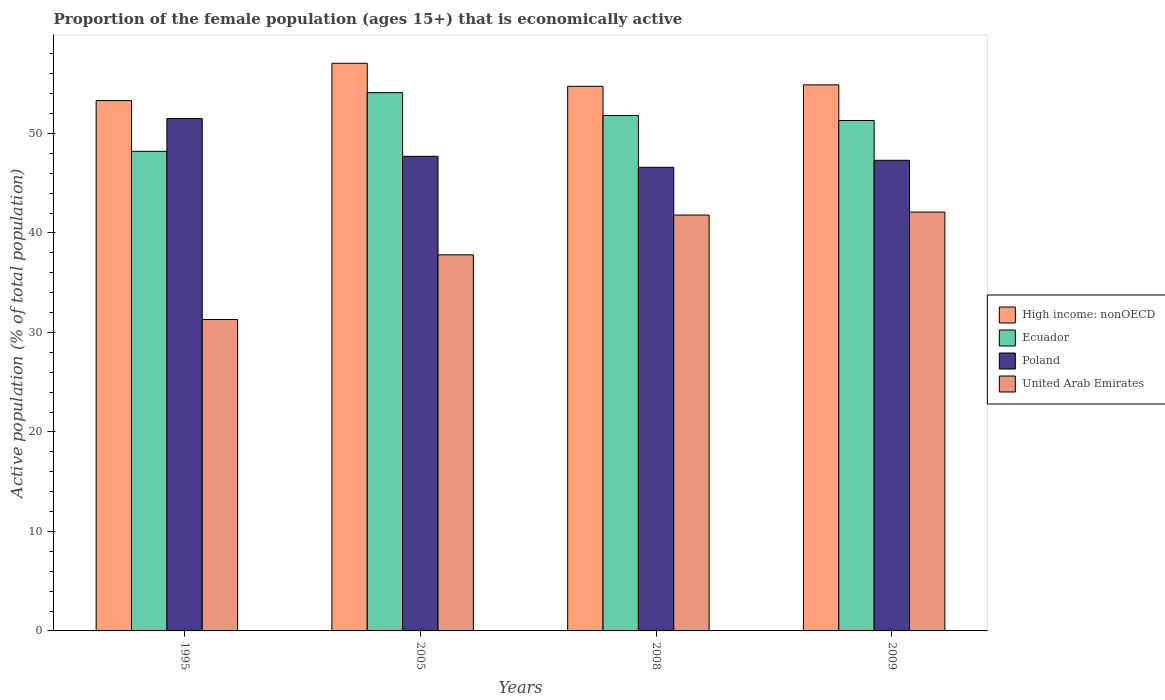How many different coloured bars are there?
Your answer should be compact. 4. Are the number of bars per tick equal to the number of legend labels?
Make the answer very short. Yes. Are the number of bars on each tick of the X-axis equal?
Ensure brevity in your answer.  Yes. How many bars are there on the 1st tick from the left?
Offer a terse response. 4. How many bars are there on the 2nd tick from the right?
Make the answer very short. 4. What is the proportion of the female population that is economically active in Ecuador in 2009?
Provide a succinct answer. 51.3. Across all years, what is the maximum proportion of the female population that is economically active in Poland?
Ensure brevity in your answer.  51.5. Across all years, what is the minimum proportion of the female population that is economically active in Ecuador?
Your answer should be very brief. 48.2. In which year was the proportion of the female population that is economically active in Ecuador minimum?
Provide a short and direct response. 1995. What is the total proportion of the female population that is economically active in High income: nonOECD in the graph?
Ensure brevity in your answer.  219.98. What is the difference between the proportion of the female population that is economically active in High income: nonOECD in 2005 and that in 2009?
Provide a succinct answer. 2.17. What is the average proportion of the female population that is economically active in United Arab Emirates per year?
Make the answer very short. 38.25. In the year 2009, what is the difference between the proportion of the female population that is economically active in Ecuador and proportion of the female population that is economically active in United Arab Emirates?
Ensure brevity in your answer.  9.2. What is the ratio of the proportion of the female population that is economically active in United Arab Emirates in 1995 to that in 2008?
Make the answer very short. 0.75. Is the proportion of the female population that is economically active in High income: nonOECD in 1995 less than that in 2005?
Provide a succinct answer. Yes. Is the difference between the proportion of the female population that is economically active in Ecuador in 1995 and 2009 greater than the difference between the proportion of the female population that is economically active in United Arab Emirates in 1995 and 2009?
Give a very brief answer. Yes. What is the difference between the highest and the second highest proportion of the female population that is economically active in High income: nonOECD?
Offer a very short reply. 2.17. What is the difference between the highest and the lowest proportion of the female population that is economically active in Ecuador?
Your response must be concise. 5.9. In how many years, is the proportion of the female population that is economically active in High income: nonOECD greater than the average proportion of the female population that is economically active in High income: nonOECD taken over all years?
Make the answer very short. 1. Is the sum of the proportion of the female population that is economically active in United Arab Emirates in 1995 and 2008 greater than the maximum proportion of the female population that is economically active in Poland across all years?
Offer a very short reply. Yes. Is it the case that in every year, the sum of the proportion of the female population that is economically active in Poland and proportion of the female population that is economically active in United Arab Emirates is greater than the sum of proportion of the female population that is economically active in High income: nonOECD and proportion of the female population that is economically active in Ecuador?
Make the answer very short. Yes. What does the 1st bar from the left in 1995 represents?
Your answer should be compact. High income: nonOECD. What does the 3rd bar from the right in 2009 represents?
Ensure brevity in your answer.  Ecuador. How many bars are there?
Your answer should be very brief. 16. What is the difference between two consecutive major ticks on the Y-axis?
Offer a terse response. 10. Are the values on the major ticks of Y-axis written in scientific E-notation?
Your response must be concise. No. Does the graph contain any zero values?
Give a very brief answer. No. How many legend labels are there?
Offer a very short reply. 4. What is the title of the graph?
Your response must be concise. Proportion of the female population (ages 15+) that is economically active. What is the label or title of the X-axis?
Keep it short and to the point. Years. What is the label or title of the Y-axis?
Offer a very short reply. Active population (% of total population). What is the Active population (% of total population) in High income: nonOECD in 1995?
Provide a succinct answer. 53.3. What is the Active population (% of total population) in Ecuador in 1995?
Keep it short and to the point. 48.2. What is the Active population (% of total population) of Poland in 1995?
Provide a short and direct response. 51.5. What is the Active population (% of total population) in United Arab Emirates in 1995?
Provide a succinct answer. 31.3. What is the Active population (% of total population) of High income: nonOECD in 2005?
Offer a terse response. 57.05. What is the Active population (% of total population) of Ecuador in 2005?
Keep it short and to the point. 54.1. What is the Active population (% of total population) of Poland in 2005?
Offer a terse response. 47.7. What is the Active population (% of total population) in United Arab Emirates in 2005?
Offer a terse response. 37.8. What is the Active population (% of total population) in High income: nonOECD in 2008?
Ensure brevity in your answer.  54.74. What is the Active population (% of total population) of Ecuador in 2008?
Your answer should be compact. 51.8. What is the Active population (% of total population) of Poland in 2008?
Offer a very short reply. 46.6. What is the Active population (% of total population) of United Arab Emirates in 2008?
Offer a very short reply. 41.8. What is the Active population (% of total population) of High income: nonOECD in 2009?
Ensure brevity in your answer.  54.88. What is the Active population (% of total population) of Ecuador in 2009?
Keep it short and to the point. 51.3. What is the Active population (% of total population) in Poland in 2009?
Offer a very short reply. 47.3. What is the Active population (% of total population) of United Arab Emirates in 2009?
Your answer should be very brief. 42.1. Across all years, what is the maximum Active population (% of total population) in High income: nonOECD?
Offer a very short reply. 57.05. Across all years, what is the maximum Active population (% of total population) of Ecuador?
Provide a succinct answer. 54.1. Across all years, what is the maximum Active population (% of total population) in Poland?
Your answer should be very brief. 51.5. Across all years, what is the maximum Active population (% of total population) of United Arab Emirates?
Your answer should be compact. 42.1. Across all years, what is the minimum Active population (% of total population) in High income: nonOECD?
Your response must be concise. 53.3. Across all years, what is the minimum Active population (% of total population) in Ecuador?
Provide a short and direct response. 48.2. Across all years, what is the minimum Active population (% of total population) of Poland?
Keep it short and to the point. 46.6. Across all years, what is the minimum Active population (% of total population) of United Arab Emirates?
Offer a terse response. 31.3. What is the total Active population (% of total population) in High income: nonOECD in the graph?
Make the answer very short. 219.98. What is the total Active population (% of total population) of Ecuador in the graph?
Give a very brief answer. 205.4. What is the total Active population (% of total population) of Poland in the graph?
Your answer should be very brief. 193.1. What is the total Active population (% of total population) of United Arab Emirates in the graph?
Ensure brevity in your answer.  153. What is the difference between the Active population (% of total population) of High income: nonOECD in 1995 and that in 2005?
Provide a succinct answer. -3.75. What is the difference between the Active population (% of total population) in Poland in 1995 and that in 2005?
Provide a succinct answer. 3.8. What is the difference between the Active population (% of total population) in United Arab Emirates in 1995 and that in 2005?
Give a very brief answer. -6.5. What is the difference between the Active population (% of total population) in High income: nonOECD in 1995 and that in 2008?
Ensure brevity in your answer.  -1.43. What is the difference between the Active population (% of total population) of Poland in 1995 and that in 2008?
Your answer should be compact. 4.9. What is the difference between the Active population (% of total population) in High income: nonOECD in 1995 and that in 2009?
Offer a very short reply. -1.58. What is the difference between the Active population (% of total population) in Poland in 1995 and that in 2009?
Your answer should be very brief. 4.2. What is the difference between the Active population (% of total population) in United Arab Emirates in 1995 and that in 2009?
Keep it short and to the point. -10.8. What is the difference between the Active population (% of total population) of High income: nonOECD in 2005 and that in 2008?
Your answer should be very brief. 2.32. What is the difference between the Active population (% of total population) of Ecuador in 2005 and that in 2008?
Keep it short and to the point. 2.3. What is the difference between the Active population (% of total population) in High income: nonOECD in 2005 and that in 2009?
Make the answer very short. 2.17. What is the difference between the Active population (% of total population) of Ecuador in 2005 and that in 2009?
Ensure brevity in your answer.  2.8. What is the difference between the Active population (% of total population) of Poland in 2005 and that in 2009?
Make the answer very short. 0.4. What is the difference between the Active population (% of total population) of High income: nonOECD in 2008 and that in 2009?
Ensure brevity in your answer.  -0.15. What is the difference between the Active population (% of total population) in Poland in 2008 and that in 2009?
Your answer should be very brief. -0.7. What is the difference between the Active population (% of total population) of United Arab Emirates in 2008 and that in 2009?
Ensure brevity in your answer.  -0.3. What is the difference between the Active population (% of total population) of High income: nonOECD in 1995 and the Active population (% of total population) of Ecuador in 2005?
Make the answer very short. -0.8. What is the difference between the Active population (% of total population) of High income: nonOECD in 1995 and the Active population (% of total population) of Poland in 2005?
Keep it short and to the point. 5.6. What is the difference between the Active population (% of total population) of High income: nonOECD in 1995 and the Active population (% of total population) of United Arab Emirates in 2005?
Keep it short and to the point. 15.5. What is the difference between the Active population (% of total population) in High income: nonOECD in 1995 and the Active population (% of total population) in Ecuador in 2008?
Make the answer very short. 1.5. What is the difference between the Active population (% of total population) of High income: nonOECD in 1995 and the Active population (% of total population) of Poland in 2008?
Make the answer very short. 6.7. What is the difference between the Active population (% of total population) in High income: nonOECD in 1995 and the Active population (% of total population) in United Arab Emirates in 2008?
Your answer should be compact. 11.5. What is the difference between the Active population (% of total population) of Ecuador in 1995 and the Active population (% of total population) of Poland in 2008?
Provide a short and direct response. 1.6. What is the difference between the Active population (% of total population) of Ecuador in 1995 and the Active population (% of total population) of United Arab Emirates in 2008?
Provide a succinct answer. 6.4. What is the difference between the Active population (% of total population) in Poland in 1995 and the Active population (% of total population) in United Arab Emirates in 2008?
Offer a terse response. 9.7. What is the difference between the Active population (% of total population) of High income: nonOECD in 1995 and the Active population (% of total population) of Ecuador in 2009?
Make the answer very short. 2. What is the difference between the Active population (% of total population) of High income: nonOECD in 1995 and the Active population (% of total population) of Poland in 2009?
Ensure brevity in your answer.  6. What is the difference between the Active population (% of total population) of High income: nonOECD in 1995 and the Active population (% of total population) of United Arab Emirates in 2009?
Give a very brief answer. 11.2. What is the difference between the Active population (% of total population) in Ecuador in 1995 and the Active population (% of total population) in United Arab Emirates in 2009?
Make the answer very short. 6.1. What is the difference between the Active population (% of total population) in High income: nonOECD in 2005 and the Active population (% of total population) in Ecuador in 2008?
Make the answer very short. 5.25. What is the difference between the Active population (% of total population) of High income: nonOECD in 2005 and the Active population (% of total population) of Poland in 2008?
Offer a very short reply. 10.45. What is the difference between the Active population (% of total population) in High income: nonOECD in 2005 and the Active population (% of total population) in United Arab Emirates in 2008?
Give a very brief answer. 15.25. What is the difference between the Active population (% of total population) in Ecuador in 2005 and the Active population (% of total population) in United Arab Emirates in 2008?
Offer a terse response. 12.3. What is the difference between the Active population (% of total population) of Poland in 2005 and the Active population (% of total population) of United Arab Emirates in 2008?
Keep it short and to the point. 5.9. What is the difference between the Active population (% of total population) of High income: nonOECD in 2005 and the Active population (% of total population) of Ecuador in 2009?
Keep it short and to the point. 5.75. What is the difference between the Active population (% of total population) of High income: nonOECD in 2005 and the Active population (% of total population) of Poland in 2009?
Your answer should be very brief. 9.75. What is the difference between the Active population (% of total population) in High income: nonOECD in 2005 and the Active population (% of total population) in United Arab Emirates in 2009?
Provide a short and direct response. 14.95. What is the difference between the Active population (% of total population) in Ecuador in 2005 and the Active population (% of total population) in Poland in 2009?
Your response must be concise. 6.8. What is the difference between the Active population (% of total population) of Poland in 2005 and the Active population (% of total population) of United Arab Emirates in 2009?
Keep it short and to the point. 5.6. What is the difference between the Active population (% of total population) in High income: nonOECD in 2008 and the Active population (% of total population) in Ecuador in 2009?
Keep it short and to the point. 3.44. What is the difference between the Active population (% of total population) in High income: nonOECD in 2008 and the Active population (% of total population) in Poland in 2009?
Keep it short and to the point. 7.44. What is the difference between the Active population (% of total population) of High income: nonOECD in 2008 and the Active population (% of total population) of United Arab Emirates in 2009?
Give a very brief answer. 12.64. What is the difference between the Active population (% of total population) of Ecuador in 2008 and the Active population (% of total population) of United Arab Emirates in 2009?
Offer a very short reply. 9.7. What is the average Active population (% of total population) in High income: nonOECD per year?
Give a very brief answer. 54.99. What is the average Active population (% of total population) in Ecuador per year?
Give a very brief answer. 51.35. What is the average Active population (% of total population) of Poland per year?
Provide a succinct answer. 48.27. What is the average Active population (% of total population) of United Arab Emirates per year?
Make the answer very short. 38.25. In the year 1995, what is the difference between the Active population (% of total population) in High income: nonOECD and Active population (% of total population) in Ecuador?
Your answer should be very brief. 5.1. In the year 1995, what is the difference between the Active population (% of total population) in High income: nonOECD and Active population (% of total population) in Poland?
Keep it short and to the point. 1.8. In the year 1995, what is the difference between the Active population (% of total population) in High income: nonOECD and Active population (% of total population) in United Arab Emirates?
Make the answer very short. 22. In the year 1995, what is the difference between the Active population (% of total population) in Ecuador and Active population (% of total population) in Poland?
Provide a short and direct response. -3.3. In the year 1995, what is the difference between the Active population (% of total population) of Ecuador and Active population (% of total population) of United Arab Emirates?
Your answer should be compact. 16.9. In the year 1995, what is the difference between the Active population (% of total population) in Poland and Active population (% of total population) in United Arab Emirates?
Provide a short and direct response. 20.2. In the year 2005, what is the difference between the Active population (% of total population) of High income: nonOECD and Active population (% of total population) of Ecuador?
Offer a very short reply. 2.95. In the year 2005, what is the difference between the Active population (% of total population) in High income: nonOECD and Active population (% of total population) in Poland?
Your answer should be very brief. 9.35. In the year 2005, what is the difference between the Active population (% of total population) in High income: nonOECD and Active population (% of total population) in United Arab Emirates?
Keep it short and to the point. 19.25. In the year 2005, what is the difference between the Active population (% of total population) in Ecuador and Active population (% of total population) in Poland?
Your answer should be compact. 6.4. In the year 2005, what is the difference between the Active population (% of total population) of Poland and Active population (% of total population) of United Arab Emirates?
Offer a terse response. 9.9. In the year 2008, what is the difference between the Active population (% of total population) of High income: nonOECD and Active population (% of total population) of Ecuador?
Offer a terse response. 2.94. In the year 2008, what is the difference between the Active population (% of total population) of High income: nonOECD and Active population (% of total population) of Poland?
Offer a terse response. 8.14. In the year 2008, what is the difference between the Active population (% of total population) in High income: nonOECD and Active population (% of total population) in United Arab Emirates?
Make the answer very short. 12.94. In the year 2009, what is the difference between the Active population (% of total population) of High income: nonOECD and Active population (% of total population) of Ecuador?
Your answer should be compact. 3.58. In the year 2009, what is the difference between the Active population (% of total population) of High income: nonOECD and Active population (% of total population) of Poland?
Offer a very short reply. 7.58. In the year 2009, what is the difference between the Active population (% of total population) in High income: nonOECD and Active population (% of total population) in United Arab Emirates?
Offer a terse response. 12.78. In the year 2009, what is the difference between the Active population (% of total population) of Poland and Active population (% of total population) of United Arab Emirates?
Provide a succinct answer. 5.2. What is the ratio of the Active population (% of total population) in High income: nonOECD in 1995 to that in 2005?
Offer a very short reply. 0.93. What is the ratio of the Active population (% of total population) of Ecuador in 1995 to that in 2005?
Your response must be concise. 0.89. What is the ratio of the Active population (% of total population) of Poland in 1995 to that in 2005?
Give a very brief answer. 1.08. What is the ratio of the Active population (% of total population) of United Arab Emirates in 1995 to that in 2005?
Ensure brevity in your answer.  0.83. What is the ratio of the Active population (% of total population) of High income: nonOECD in 1995 to that in 2008?
Provide a succinct answer. 0.97. What is the ratio of the Active population (% of total population) in Ecuador in 1995 to that in 2008?
Ensure brevity in your answer.  0.93. What is the ratio of the Active population (% of total population) of Poland in 1995 to that in 2008?
Your answer should be very brief. 1.11. What is the ratio of the Active population (% of total population) in United Arab Emirates in 1995 to that in 2008?
Ensure brevity in your answer.  0.75. What is the ratio of the Active population (% of total population) of High income: nonOECD in 1995 to that in 2009?
Make the answer very short. 0.97. What is the ratio of the Active population (% of total population) of Ecuador in 1995 to that in 2009?
Your answer should be very brief. 0.94. What is the ratio of the Active population (% of total population) in Poland in 1995 to that in 2009?
Offer a very short reply. 1.09. What is the ratio of the Active population (% of total population) of United Arab Emirates in 1995 to that in 2009?
Your answer should be very brief. 0.74. What is the ratio of the Active population (% of total population) in High income: nonOECD in 2005 to that in 2008?
Provide a succinct answer. 1.04. What is the ratio of the Active population (% of total population) of Ecuador in 2005 to that in 2008?
Provide a succinct answer. 1.04. What is the ratio of the Active population (% of total population) in Poland in 2005 to that in 2008?
Give a very brief answer. 1.02. What is the ratio of the Active population (% of total population) in United Arab Emirates in 2005 to that in 2008?
Offer a very short reply. 0.9. What is the ratio of the Active population (% of total population) of High income: nonOECD in 2005 to that in 2009?
Your answer should be very brief. 1.04. What is the ratio of the Active population (% of total population) of Ecuador in 2005 to that in 2009?
Offer a terse response. 1.05. What is the ratio of the Active population (% of total population) in Poland in 2005 to that in 2009?
Keep it short and to the point. 1.01. What is the ratio of the Active population (% of total population) of United Arab Emirates in 2005 to that in 2009?
Your response must be concise. 0.9. What is the ratio of the Active population (% of total population) in Ecuador in 2008 to that in 2009?
Ensure brevity in your answer.  1.01. What is the ratio of the Active population (% of total population) in Poland in 2008 to that in 2009?
Give a very brief answer. 0.99. What is the ratio of the Active population (% of total population) in United Arab Emirates in 2008 to that in 2009?
Keep it short and to the point. 0.99. What is the difference between the highest and the second highest Active population (% of total population) of High income: nonOECD?
Ensure brevity in your answer.  2.17. What is the difference between the highest and the second highest Active population (% of total population) of Ecuador?
Keep it short and to the point. 2.3. What is the difference between the highest and the second highest Active population (% of total population) of Poland?
Offer a very short reply. 3.8. What is the difference between the highest and the second highest Active population (% of total population) in United Arab Emirates?
Provide a short and direct response. 0.3. What is the difference between the highest and the lowest Active population (% of total population) of High income: nonOECD?
Your answer should be very brief. 3.75. What is the difference between the highest and the lowest Active population (% of total population) of United Arab Emirates?
Offer a terse response. 10.8. 